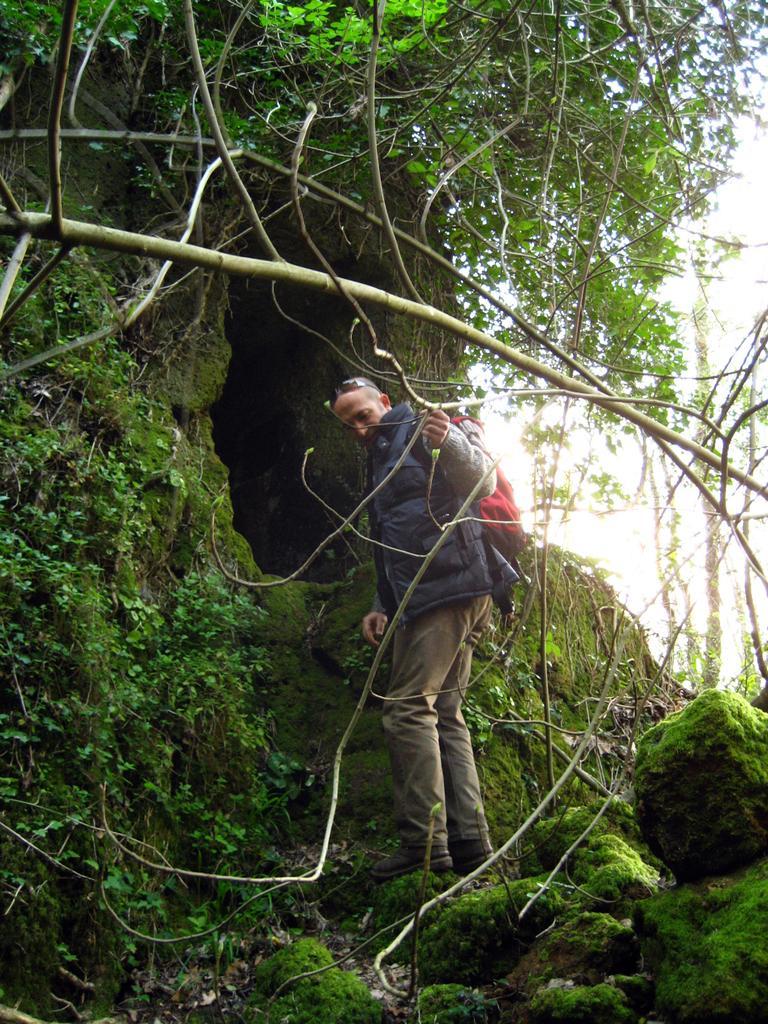Could you give a brief overview of what you see in this image? In this image, we can see a person. We can see some plants, trees and stones. We can also see a cave and the sky. 